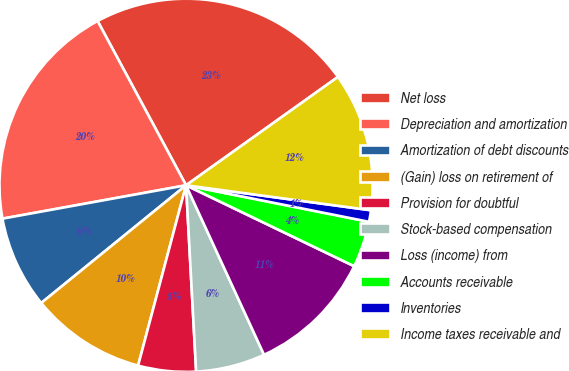Convert chart. <chart><loc_0><loc_0><loc_500><loc_500><pie_chart><fcel>Net loss<fcel>Depreciation and amortization<fcel>Amortization of debt discounts<fcel>(Gain) loss on retirement of<fcel>Provision for doubtful<fcel>Stock-based compensation<fcel>Loss (income) from<fcel>Accounts receivable<fcel>Inventories<fcel>Income taxes receivable and<nl><fcel>23.0%<fcel>20.0%<fcel>8.0%<fcel>10.0%<fcel>5.0%<fcel>6.0%<fcel>11.0%<fcel>4.0%<fcel>1.0%<fcel>12.0%<nl></chart> 